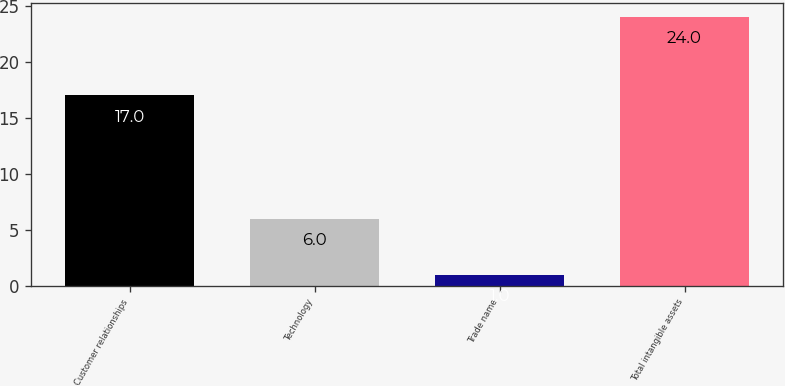<chart> <loc_0><loc_0><loc_500><loc_500><bar_chart><fcel>Customer relationships<fcel>Technology<fcel>Trade name<fcel>Total intangible assets<nl><fcel>17<fcel>6<fcel>1<fcel>24<nl></chart> 